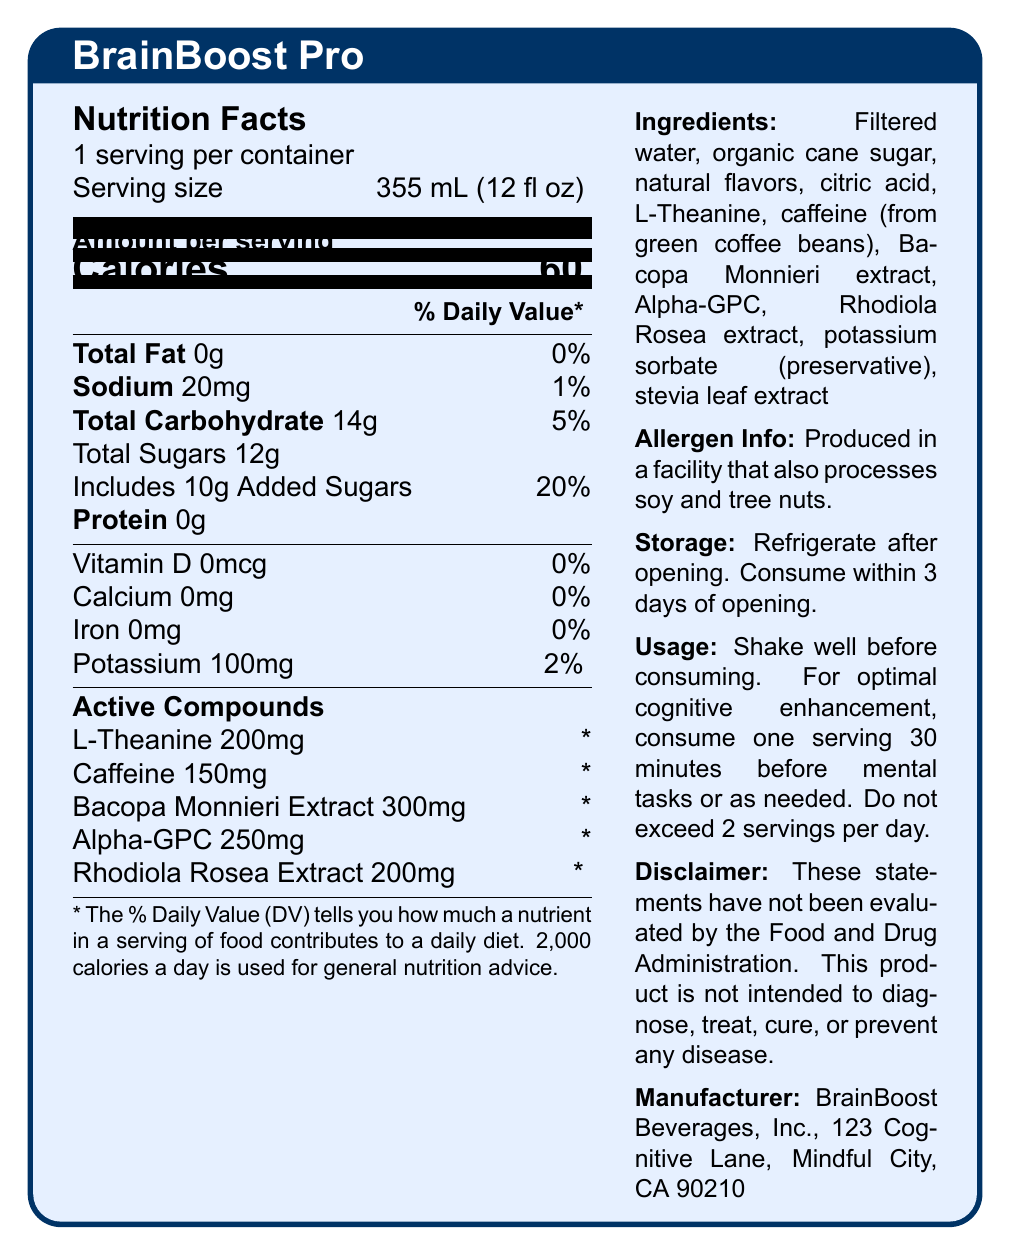what is the serving size of BrainBoost Pro? The serving size is explicitly mentioned as "355 mL (12 fl oz)" in the nutrition facts section.
Answer: 355 mL (12 fl oz) how many calories are there per serving? The document states that there are 60 calories per serving.
Answer: 60 what is the amount of protein per serving? The amount of protein per serving is listed as "0g" in the Nutrition Facts.
Answer: 0g list the active compounds and their amounts in BrainBoost Pro. The active compounds and their amounts are listed in the Active Compounds section.
Answer: L-Theanine 200mg, Caffeine 150mg, Bacopa Monnieri Extract 300mg, Alpha-GPC 250mg, Rhodiola Rosea Extract 200mg what is the daily value percentage for added sugars in one serving? The document indicates that the daily value percentage for added sugars is 20%.
Answer: 20% what is the recommended usage for optimal cognitive enhancement? The usage instructions state to consume one serving 30 minutes before mental tasks or as needed, and not to exceed 2 servings per day.
Answer: Consume one serving 30 minutes before mental tasks or as needed. Do not exceed 2 servings per day. which of the following compounds is not listed as an active compound in BrainBoost Pro? A. L-Theanine B. Caffeine C. Bacopa Monnieri Extract D. Ginkgo Biloba Ginkgo Biloba is not listed among the active compounds provided (L-Theanine, Caffeine, Bacopa Monnieri Extract, Alpha-GPC, Rhodiola Rosea Extract).
Answer: D. Ginkgo Biloba how much sodium does one serving contain? A. 0mg B. 20mg C. 100mg D. 200mg Sodium content per serving is specified as 20mg in the Nutrition Facts.
Answer: B. 20mg is BrainBoost Pro free of allergens? The allergen information states: "Produced in a facility that also processes soy and tree nuts."
Answer: No do you need to refrigerate BrainBoost Pro after opening? The storage instructions mention that the beverage should be refrigerated after opening.
Answer: Yes what main idea does the document convey? The document provides comprehensive information on BrainBoost Pro, including its nutrition facts, cognitive-enhancing active compounds, ingredients, allergen warnings, storage and usage guidelines, and manufacturer details.
Answer: Information about the nutritional content, active compounds, ingredients, allergen information, and usage instructions for BrainBoost Pro, a nootropic beverage designed to enhance cognitive performance. how many servings are there per container? The document states that there is 1 serving per container.
Answer: 1 which company manufactures BrainBoost Pro? The manufacturer information section specifies the company as BrainBoost Beverages, Inc.
Answer: BrainBoost Beverages, Inc. how much potassium is in one serving of BrainBoost Pro? The nutrition facts indicate that one serving contains 100mg of potassium.
Answer: 100mg how much L-Theanine is present in one serving? The document lists L-Theanine as containing 200mg per serving.
Answer: 200mg can BrainBoost Pro treat or cure diseases? The disclaimer states that the product is not intended to diagnose, treat, cure, or prevent any disease.
Answer: No what is the total amount of carbohydrates in a serving of BrainBoost Pro? The document lists total carbohydrates as 14g per serving.
Answer: 14g does BrainBoost Pro contain artificial flavors? The ingredients list includes natural flavors, not artificial ones.
Answer: No 